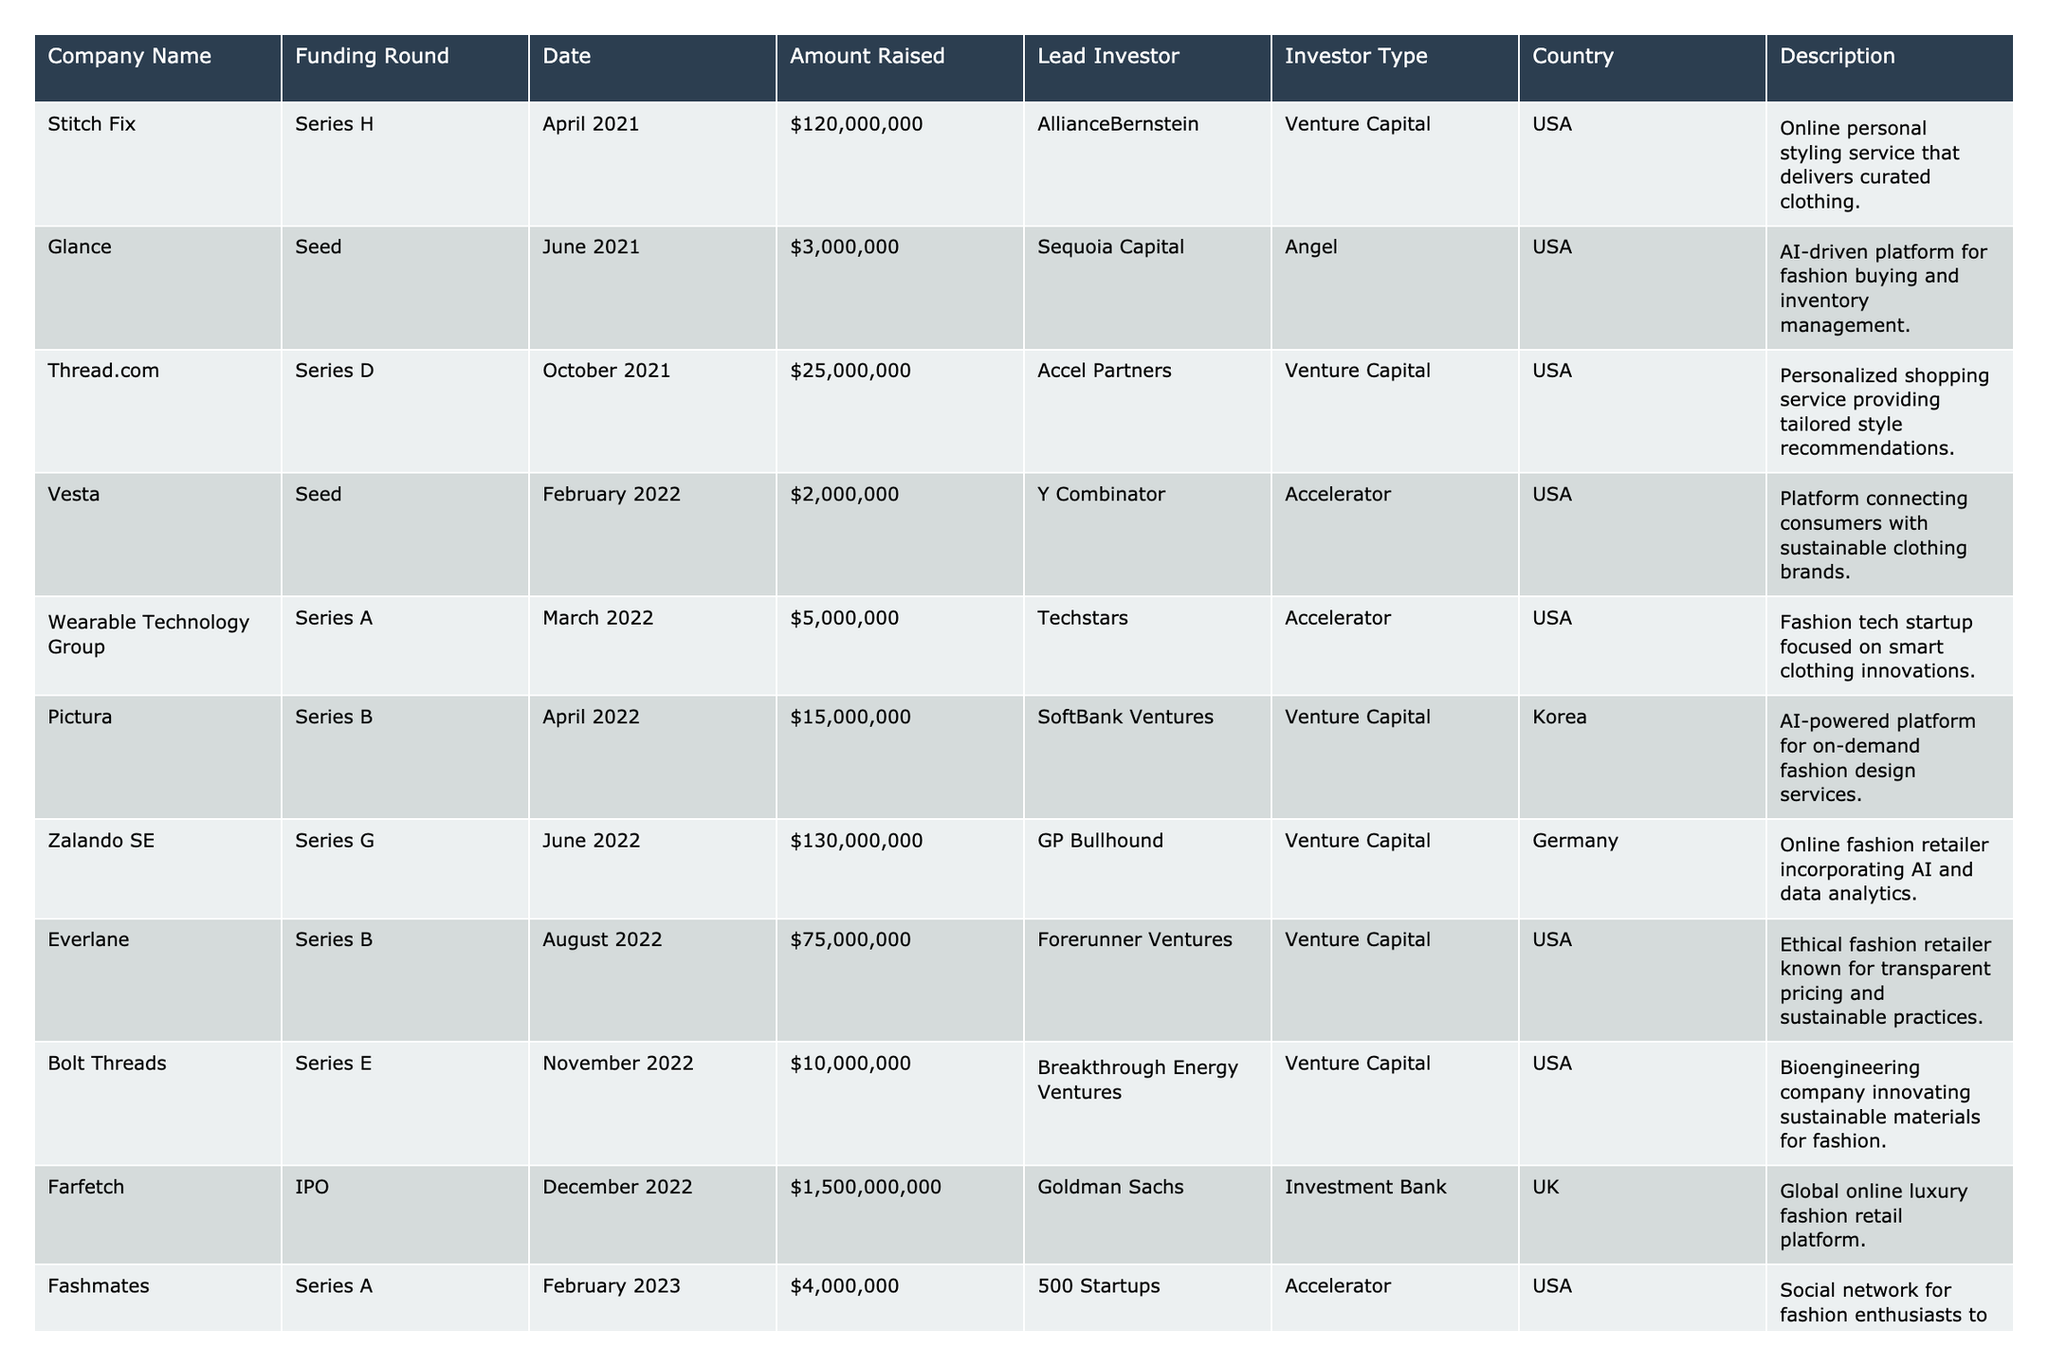What is the total amount raised in funding rounds from UK-based companies? According to the table, the only UK-based company is Farfetch, which raised $1,500,000,000 in its IPO. Therefore, the total amount raised from UK-based companies is $1,500,000,000.
Answer: $1,500,000,000 How many companies have completed a Seed funding round? Referring to the table, the companies that completed Seed rounds are Glance, Vesta, Clara, and SIR ⎯ Stylish Instant Rental, totaling four companies.
Answer: 4 Which company has the highest funding round amount, and what is the amount? The table shows that Farfetch had the highest funding round, with an amount of $1,500,000,000 raised during its IPO.
Answer: Farfetch, $1,500,000,000 What is the average amount raised by companies based in the USA? The amounts raised by USA-based companies are 120,000,000, 3,000,000, 25,000,000, 2,000,000, 5,000,000, 75,000,000, 10,000,000, 1,500,000,000, 4,000,000, 30,000,000, and 5,000,000. Summing these gives 1,570,000,000. There are 11 companies, so the average is 1,570,000,000 / 11 = 142,727,273, or approximately $142.73 million.
Answer: $142.73 million Which investor type has the most companies participating in funding rounds? Looking at the investor types in the table, there are 7 Venture Capital entries, 5 Accelerators, 1 Angel, and 1 Investment Bank. Therefore, Venture Capital is the most prevalent investor type.
Answer: Venture Capital Is there any company that raised the same amount in its funding round? By checking the amounts raised, we find that SIR ⎯ Stylish Instant Rental and Clara both raised $5,000,000, confirming that indeed there are companies with the same funding amount.
Answer: Yes What percentage of total amounts raised is attributed to the Series funding rounds? First, we sum the amounts for all rounds and then identify the amounts raised in Series rounds: $120,000,000 (H) + $25,000,000 (D) + $2,000,000 (A) + $15,000,000 (B) + $30,000,000 (E) + $6,000,000 (B). The total for Series rounds is $198,000,000. The total amount raised by all companies is $1,787,000,000. The percentage of Series funds is (198,000,000 / 1,787,000,000) * 100 = approximately 11.08%.
Answer: 11.08% Which country had the highest number of participating startups in funding rounds? Observing the list, the USA has 8 participating startups, while other countries have fewer. Hence, the USA had the highest number of startups in funding rounds.
Answer: USA Which lead investor has funded the most companies? By reviewing the lead investors, we find that AllianceBernstein, Sequoia Capital, Accel Partners, Y Combinator, Techstars, SoftBank Ventures, GP Bullhound, Forerunner Ventures, Breakthrough Energy Ventures, Goldman Sachs, 500 Startups, L Catterton, Mindshift Capital, Alpha Partners, and Coatue Management each funded one company or the investors AllianceBernstein, Sequoia Capital, Accel Partners, and Y Combinator fund two each since they started in one seed stage. The lead investors mainly have one company financed, thus no one has funded more than two or three.
Answer: No clear lead investor 